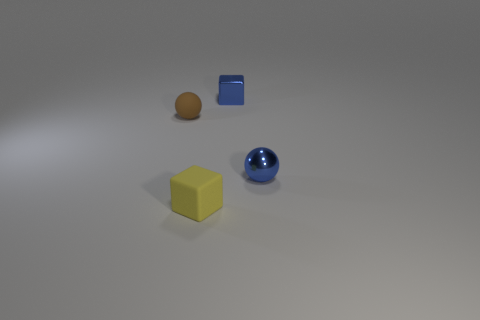There is a tiny sphere right of the blue thing to the left of the blue thing in front of the brown rubber ball; what is its material?
Your response must be concise. Metal. Is the number of metallic cubes that are left of the blue metallic block greater than the number of tiny shiny balls?
Give a very brief answer. No. There is a block that is the same size as the yellow thing; what is it made of?
Your answer should be very brief. Metal. Is there a metal ball that has the same size as the yellow rubber thing?
Offer a terse response. Yes. What size is the cube that is behind the small yellow thing?
Keep it short and to the point. Small. What is the size of the brown thing?
Give a very brief answer. Small. What number of cylinders are either tiny brown things or small yellow rubber objects?
Provide a succinct answer. 0. The thing that is the same material as the tiny blue sphere is what size?
Provide a succinct answer. Small. How many small rubber things are the same color as the small rubber ball?
Your answer should be compact. 0. There is a brown object; are there any small yellow blocks behind it?
Offer a very short reply. No. 